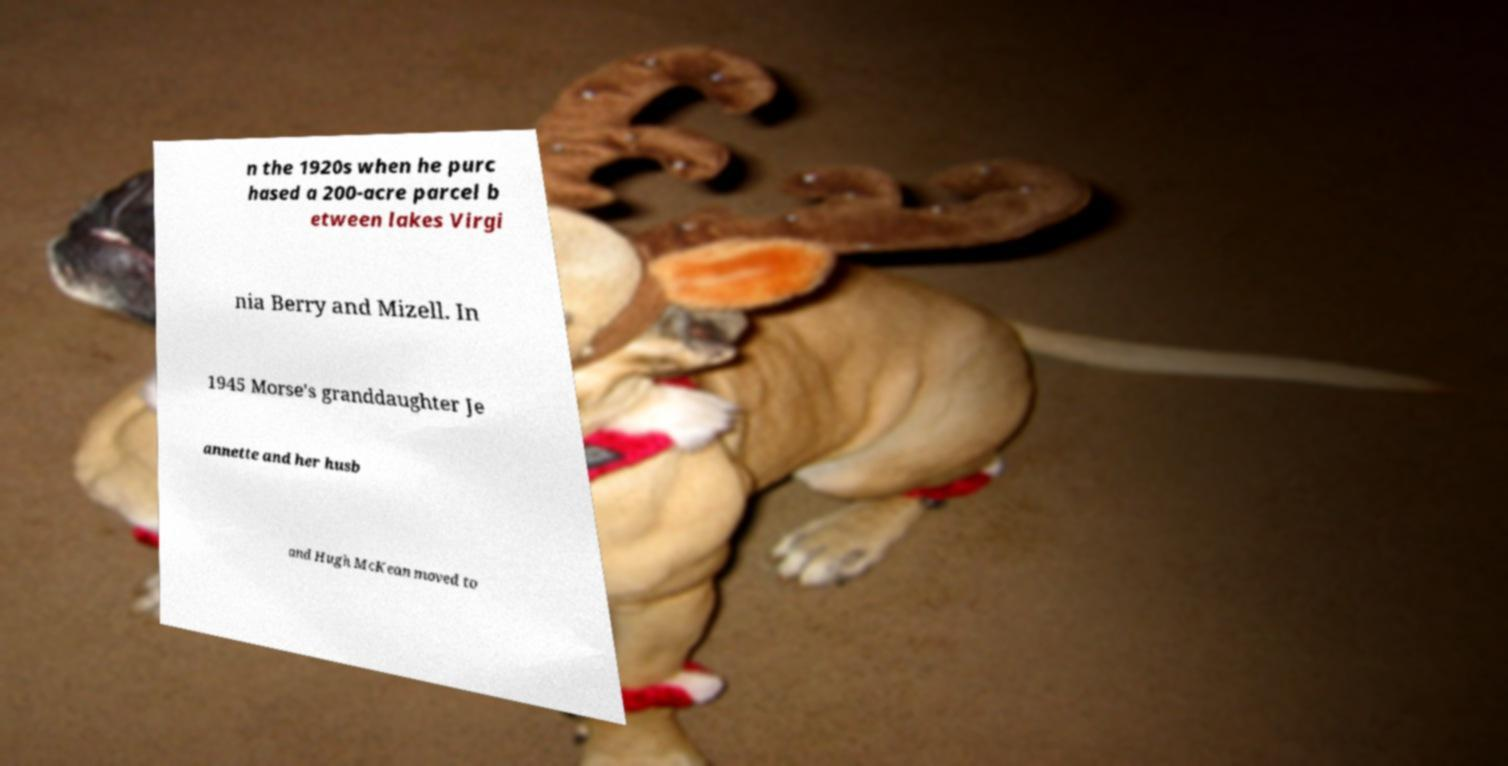There's text embedded in this image that I need extracted. Can you transcribe it verbatim? n the 1920s when he purc hased a 200-acre parcel b etween lakes Virgi nia Berry and Mizell. In 1945 Morse's granddaughter Je annette and her husb and Hugh McKean moved to 